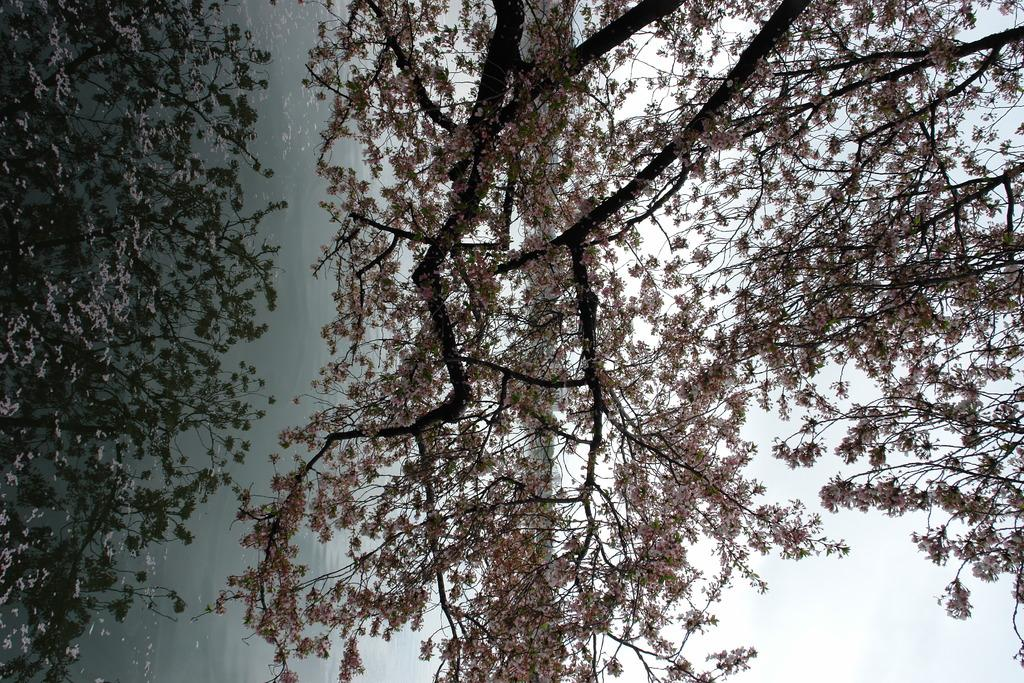What type of natural element can be seen in the image? There is a tree in the image. What is the body of water in the image? There is water in the image. What can be seen in the background of the image? The sky is visible in the background of the image. What effect can be observed on the water's surface in the image? There are reflections on the water in the image. How many chairs are placed around the tree in the image? There are no chairs present in the image; it features a tree and water with reflections. 